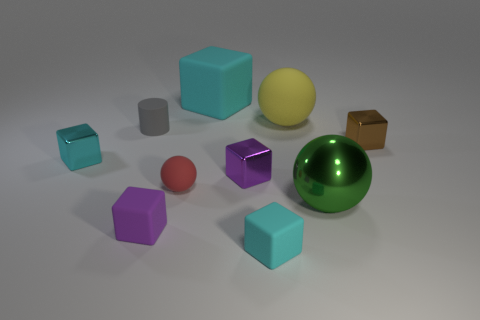What number of matte things are either large yellow objects or tiny red cylinders?
Keep it short and to the point. 1. There is a cyan matte thing in front of the big object that is in front of the tiny matte cylinder; what shape is it?
Offer a very short reply. Cube. Is the number of large cyan objects on the left side of the small gray object less than the number of small red rubber spheres?
Keep it short and to the point. Yes. The large green object is what shape?
Provide a succinct answer. Sphere. What size is the purple cube that is in front of the green metal thing?
Give a very brief answer. Small. There is a rubber cube that is the same size as the green sphere; what color is it?
Your response must be concise. Cyan. Is there another matte block of the same color as the large block?
Your answer should be compact. Yes. Is the number of cyan shiny things that are right of the rubber cylinder less than the number of cyan things to the left of the large rubber block?
Your answer should be very brief. Yes. What material is the tiny cube that is both left of the brown object and behind the purple metal cube?
Provide a succinct answer. Metal. There is a big metal object; is it the same shape as the cyan matte thing that is in front of the big green ball?
Give a very brief answer. No. 